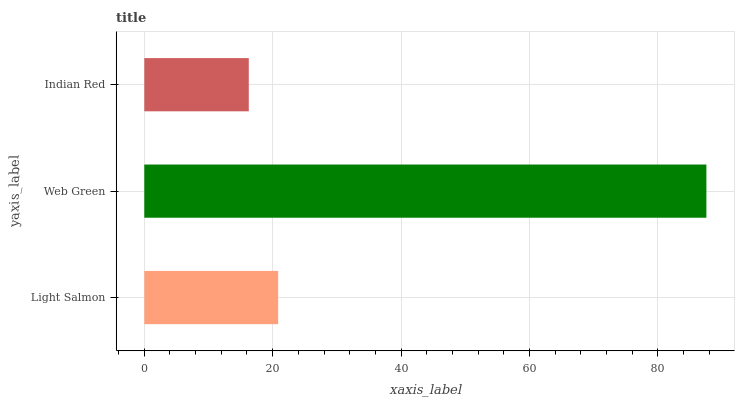Is Indian Red the minimum?
Answer yes or no. Yes. Is Web Green the maximum?
Answer yes or no. Yes. Is Web Green the minimum?
Answer yes or no. No. Is Indian Red the maximum?
Answer yes or no. No. Is Web Green greater than Indian Red?
Answer yes or no. Yes. Is Indian Red less than Web Green?
Answer yes or no. Yes. Is Indian Red greater than Web Green?
Answer yes or no. No. Is Web Green less than Indian Red?
Answer yes or no. No. Is Light Salmon the high median?
Answer yes or no. Yes. Is Light Salmon the low median?
Answer yes or no. Yes. Is Indian Red the high median?
Answer yes or no. No. Is Indian Red the low median?
Answer yes or no. No. 